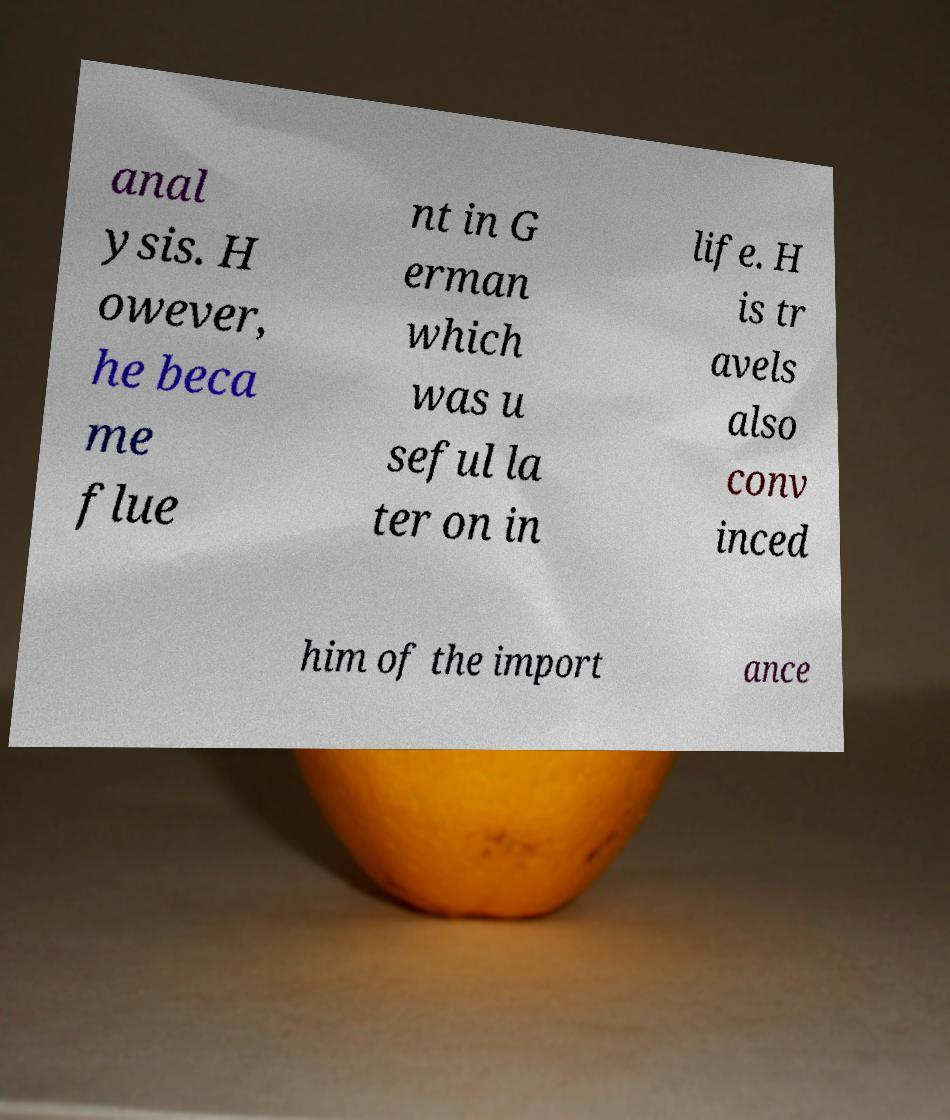Please read and relay the text visible in this image. What does it say? anal ysis. H owever, he beca me flue nt in G erman which was u seful la ter on in life. H is tr avels also conv inced him of the import ance 